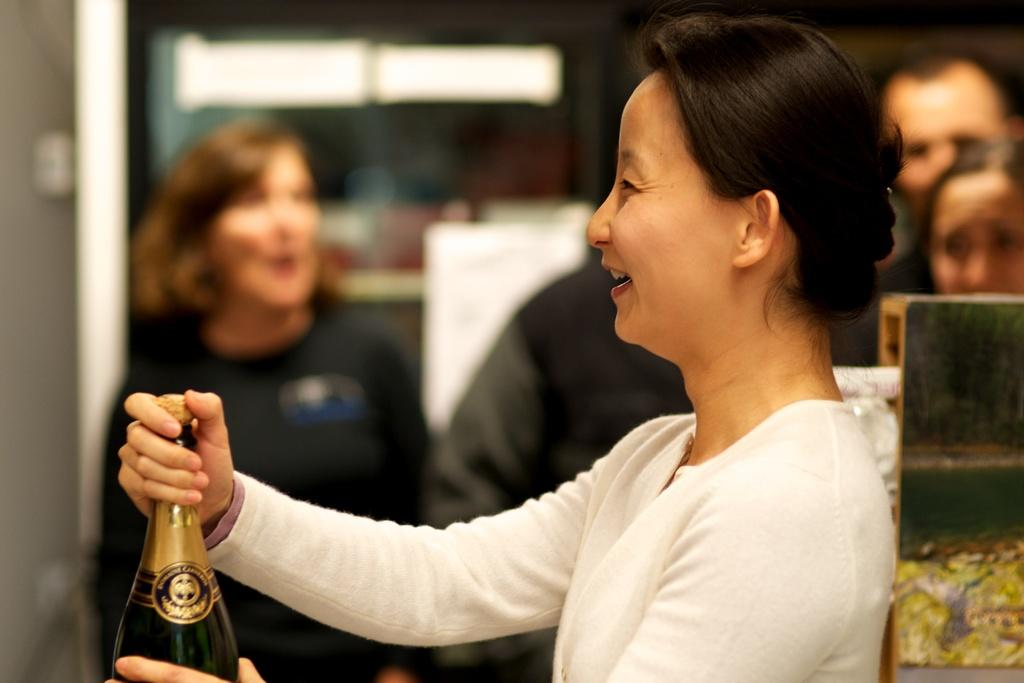Who is the main subject in the image? There is a woman in the image. What is the woman holding in the image? The woman is holding a bottle. What is the woman's facial expression in the image? The woman is smiling. Can you describe the background of the image? There are people standing in the background of the image, and there is a window visible. What type of organization is the woman a part of in the image? There is no information about any organization in the image; it only shows a woman holding a bottle and smiling. What fictional character does the woman resemble in the image? There is no fictional character mentioned or depicted in the image; it only shows a woman holding a bottle and smiling. 